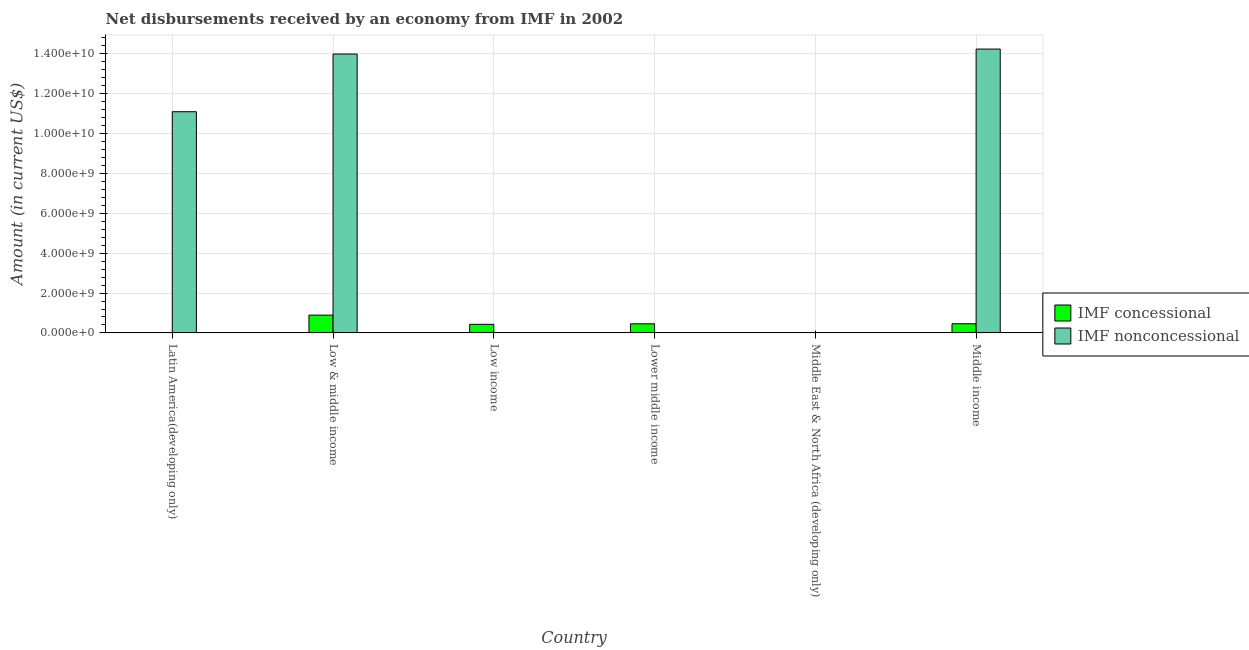What is the label of the 5th group of bars from the left?
Make the answer very short. Middle East & North Africa (developing only). What is the net concessional disbursements from imf in Low income?
Give a very brief answer. 4.32e+08. Across all countries, what is the maximum net concessional disbursements from imf?
Provide a succinct answer. 8.93e+08. What is the total net concessional disbursements from imf in the graph?
Provide a succinct answer. 2.25e+09. What is the difference between the net concessional disbursements from imf in Lower middle income and that in Middle income?
Provide a succinct answer. -3.73e+06. What is the difference between the net non concessional disbursements from imf in Lower middle income and the net concessional disbursements from imf in Low income?
Make the answer very short. -4.32e+08. What is the average net concessional disbursements from imf per country?
Your answer should be very brief. 3.75e+08. What is the difference between the net non concessional disbursements from imf and net concessional disbursements from imf in Middle income?
Ensure brevity in your answer.  1.38e+1. In how many countries, is the net non concessional disbursements from imf greater than 10400000000 US$?
Keep it short and to the point. 3. What is the ratio of the net concessional disbursements from imf in Middle East & North Africa (developing only) to that in Middle income?
Provide a short and direct response. 0.01. Is the net concessional disbursements from imf in Low income less than that in Middle income?
Ensure brevity in your answer.  Yes. What is the difference between the highest and the second highest net concessional disbursements from imf?
Give a very brief answer. 4.32e+08. What is the difference between the highest and the lowest net concessional disbursements from imf?
Offer a very short reply. 8.93e+08. Is the sum of the net concessional disbursements from imf in Low & middle income and Lower middle income greater than the maximum net non concessional disbursements from imf across all countries?
Ensure brevity in your answer.  No. Are all the bars in the graph horizontal?
Make the answer very short. No. How many countries are there in the graph?
Ensure brevity in your answer.  6. Where does the legend appear in the graph?
Give a very brief answer. Center right. How many legend labels are there?
Provide a short and direct response. 2. What is the title of the graph?
Make the answer very short. Net disbursements received by an economy from IMF in 2002. What is the label or title of the Y-axis?
Provide a succinct answer. Amount (in current US$). What is the Amount (in current US$) of IMF concessional in Latin America(developing only)?
Your response must be concise. 0. What is the Amount (in current US$) in IMF nonconcessional in Latin America(developing only)?
Offer a terse response. 1.11e+1. What is the Amount (in current US$) in IMF concessional in Low & middle income?
Offer a terse response. 8.93e+08. What is the Amount (in current US$) in IMF nonconcessional in Low & middle income?
Make the answer very short. 1.40e+1. What is the Amount (in current US$) of IMF concessional in Low income?
Offer a very short reply. 4.32e+08. What is the Amount (in current US$) in IMF nonconcessional in Low income?
Keep it short and to the point. 0. What is the Amount (in current US$) of IMF concessional in Lower middle income?
Provide a short and direct response. 4.57e+08. What is the Amount (in current US$) of IMF nonconcessional in Lower middle income?
Your response must be concise. 0. What is the Amount (in current US$) of IMF concessional in Middle East & North Africa (developing only)?
Ensure brevity in your answer.  5.88e+06. What is the Amount (in current US$) of IMF nonconcessional in Middle East & North Africa (developing only)?
Provide a short and direct response. 0. What is the Amount (in current US$) of IMF concessional in Middle income?
Give a very brief answer. 4.61e+08. What is the Amount (in current US$) in IMF nonconcessional in Middle income?
Your response must be concise. 1.42e+1. Across all countries, what is the maximum Amount (in current US$) of IMF concessional?
Offer a terse response. 8.93e+08. Across all countries, what is the maximum Amount (in current US$) of IMF nonconcessional?
Offer a terse response. 1.42e+1. Across all countries, what is the minimum Amount (in current US$) in IMF nonconcessional?
Offer a very short reply. 0. What is the total Amount (in current US$) in IMF concessional in the graph?
Ensure brevity in your answer.  2.25e+09. What is the total Amount (in current US$) of IMF nonconcessional in the graph?
Offer a very short reply. 3.93e+1. What is the difference between the Amount (in current US$) in IMF nonconcessional in Latin America(developing only) and that in Low & middle income?
Offer a terse response. -2.89e+09. What is the difference between the Amount (in current US$) of IMF nonconcessional in Latin America(developing only) and that in Middle income?
Provide a succinct answer. -3.14e+09. What is the difference between the Amount (in current US$) of IMF concessional in Low & middle income and that in Low income?
Your response must be concise. 4.61e+08. What is the difference between the Amount (in current US$) in IMF concessional in Low & middle income and that in Lower middle income?
Ensure brevity in your answer.  4.36e+08. What is the difference between the Amount (in current US$) of IMF concessional in Low & middle income and that in Middle East & North Africa (developing only)?
Make the answer very short. 8.87e+08. What is the difference between the Amount (in current US$) of IMF concessional in Low & middle income and that in Middle income?
Provide a short and direct response. 4.32e+08. What is the difference between the Amount (in current US$) of IMF nonconcessional in Low & middle income and that in Middle income?
Offer a very short reply. -2.48e+08. What is the difference between the Amount (in current US$) of IMF concessional in Low income and that in Lower middle income?
Make the answer very short. -2.49e+07. What is the difference between the Amount (in current US$) in IMF concessional in Low income and that in Middle East & North Africa (developing only)?
Your response must be concise. 4.26e+08. What is the difference between the Amount (in current US$) in IMF concessional in Low income and that in Middle income?
Offer a very short reply. -2.87e+07. What is the difference between the Amount (in current US$) in IMF concessional in Lower middle income and that in Middle East & North Africa (developing only)?
Your response must be concise. 4.51e+08. What is the difference between the Amount (in current US$) of IMF concessional in Lower middle income and that in Middle income?
Provide a succinct answer. -3.73e+06. What is the difference between the Amount (in current US$) of IMF concessional in Middle East & North Africa (developing only) and that in Middle income?
Keep it short and to the point. -4.55e+08. What is the difference between the Amount (in current US$) of IMF concessional in Low & middle income and the Amount (in current US$) of IMF nonconcessional in Middle income?
Keep it short and to the point. -1.33e+1. What is the difference between the Amount (in current US$) in IMF concessional in Low income and the Amount (in current US$) in IMF nonconcessional in Middle income?
Provide a short and direct response. -1.38e+1. What is the difference between the Amount (in current US$) of IMF concessional in Lower middle income and the Amount (in current US$) of IMF nonconcessional in Middle income?
Make the answer very short. -1.38e+1. What is the difference between the Amount (in current US$) in IMF concessional in Middle East & North Africa (developing only) and the Amount (in current US$) in IMF nonconcessional in Middle income?
Your response must be concise. -1.42e+1. What is the average Amount (in current US$) in IMF concessional per country?
Keep it short and to the point. 3.75e+08. What is the average Amount (in current US$) in IMF nonconcessional per country?
Ensure brevity in your answer.  6.55e+09. What is the difference between the Amount (in current US$) in IMF concessional and Amount (in current US$) in IMF nonconcessional in Low & middle income?
Ensure brevity in your answer.  -1.31e+1. What is the difference between the Amount (in current US$) of IMF concessional and Amount (in current US$) of IMF nonconcessional in Middle income?
Your answer should be very brief. -1.38e+1. What is the ratio of the Amount (in current US$) in IMF nonconcessional in Latin America(developing only) to that in Low & middle income?
Keep it short and to the point. 0.79. What is the ratio of the Amount (in current US$) of IMF nonconcessional in Latin America(developing only) to that in Middle income?
Your answer should be compact. 0.78. What is the ratio of the Amount (in current US$) of IMF concessional in Low & middle income to that in Low income?
Offer a terse response. 2.07. What is the ratio of the Amount (in current US$) of IMF concessional in Low & middle income to that in Lower middle income?
Provide a short and direct response. 1.95. What is the ratio of the Amount (in current US$) of IMF concessional in Low & middle income to that in Middle East & North Africa (developing only)?
Provide a succinct answer. 151.85. What is the ratio of the Amount (in current US$) in IMF concessional in Low & middle income to that in Middle income?
Provide a succinct answer. 1.94. What is the ratio of the Amount (in current US$) in IMF nonconcessional in Low & middle income to that in Middle income?
Make the answer very short. 0.98. What is the ratio of the Amount (in current US$) in IMF concessional in Low income to that in Lower middle income?
Offer a very short reply. 0.95. What is the ratio of the Amount (in current US$) of IMF concessional in Low income to that in Middle East & North Africa (developing only)?
Make the answer very short. 73.49. What is the ratio of the Amount (in current US$) in IMF concessional in Low income to that in Middle income?
Provide a short and direct response. 0.94. What is the ratio of the Amount (in current US$) in IMF concessional in Lower middle income to that in Middle East & North Africa (developing only)?
Provide a short and direct response. 77.73. What is the ratio of the Amount (in current US$) of IMF concessional in Lower middle income to that in Middle income?
Make the answer very short. 0.99. What is the ratio of the Amount (in current US$) of IMF concessional in Middle East & North Africa (developing only) to that in Middle income?
Your answer should be very brief. 0.01. What is the difference between the highest and the second highest Amount (in current US$) of IMF concessional?
Provide a short and direct response. 4.32e+08. What is the difference between the highest and the second highest Amount (in current US$) in IMF nonconcessional?
Your answer should be compact. 2.48e+08. What is the difference between the highest and the lowest Amount (in current US$) of IMF concessional?
Give a very brief answer. 8.93e+08. What is the difference between the highest and the lowest Amount (in current US$) in IMF nonconcessional?
Offer a terse response. 1.42e+1. 